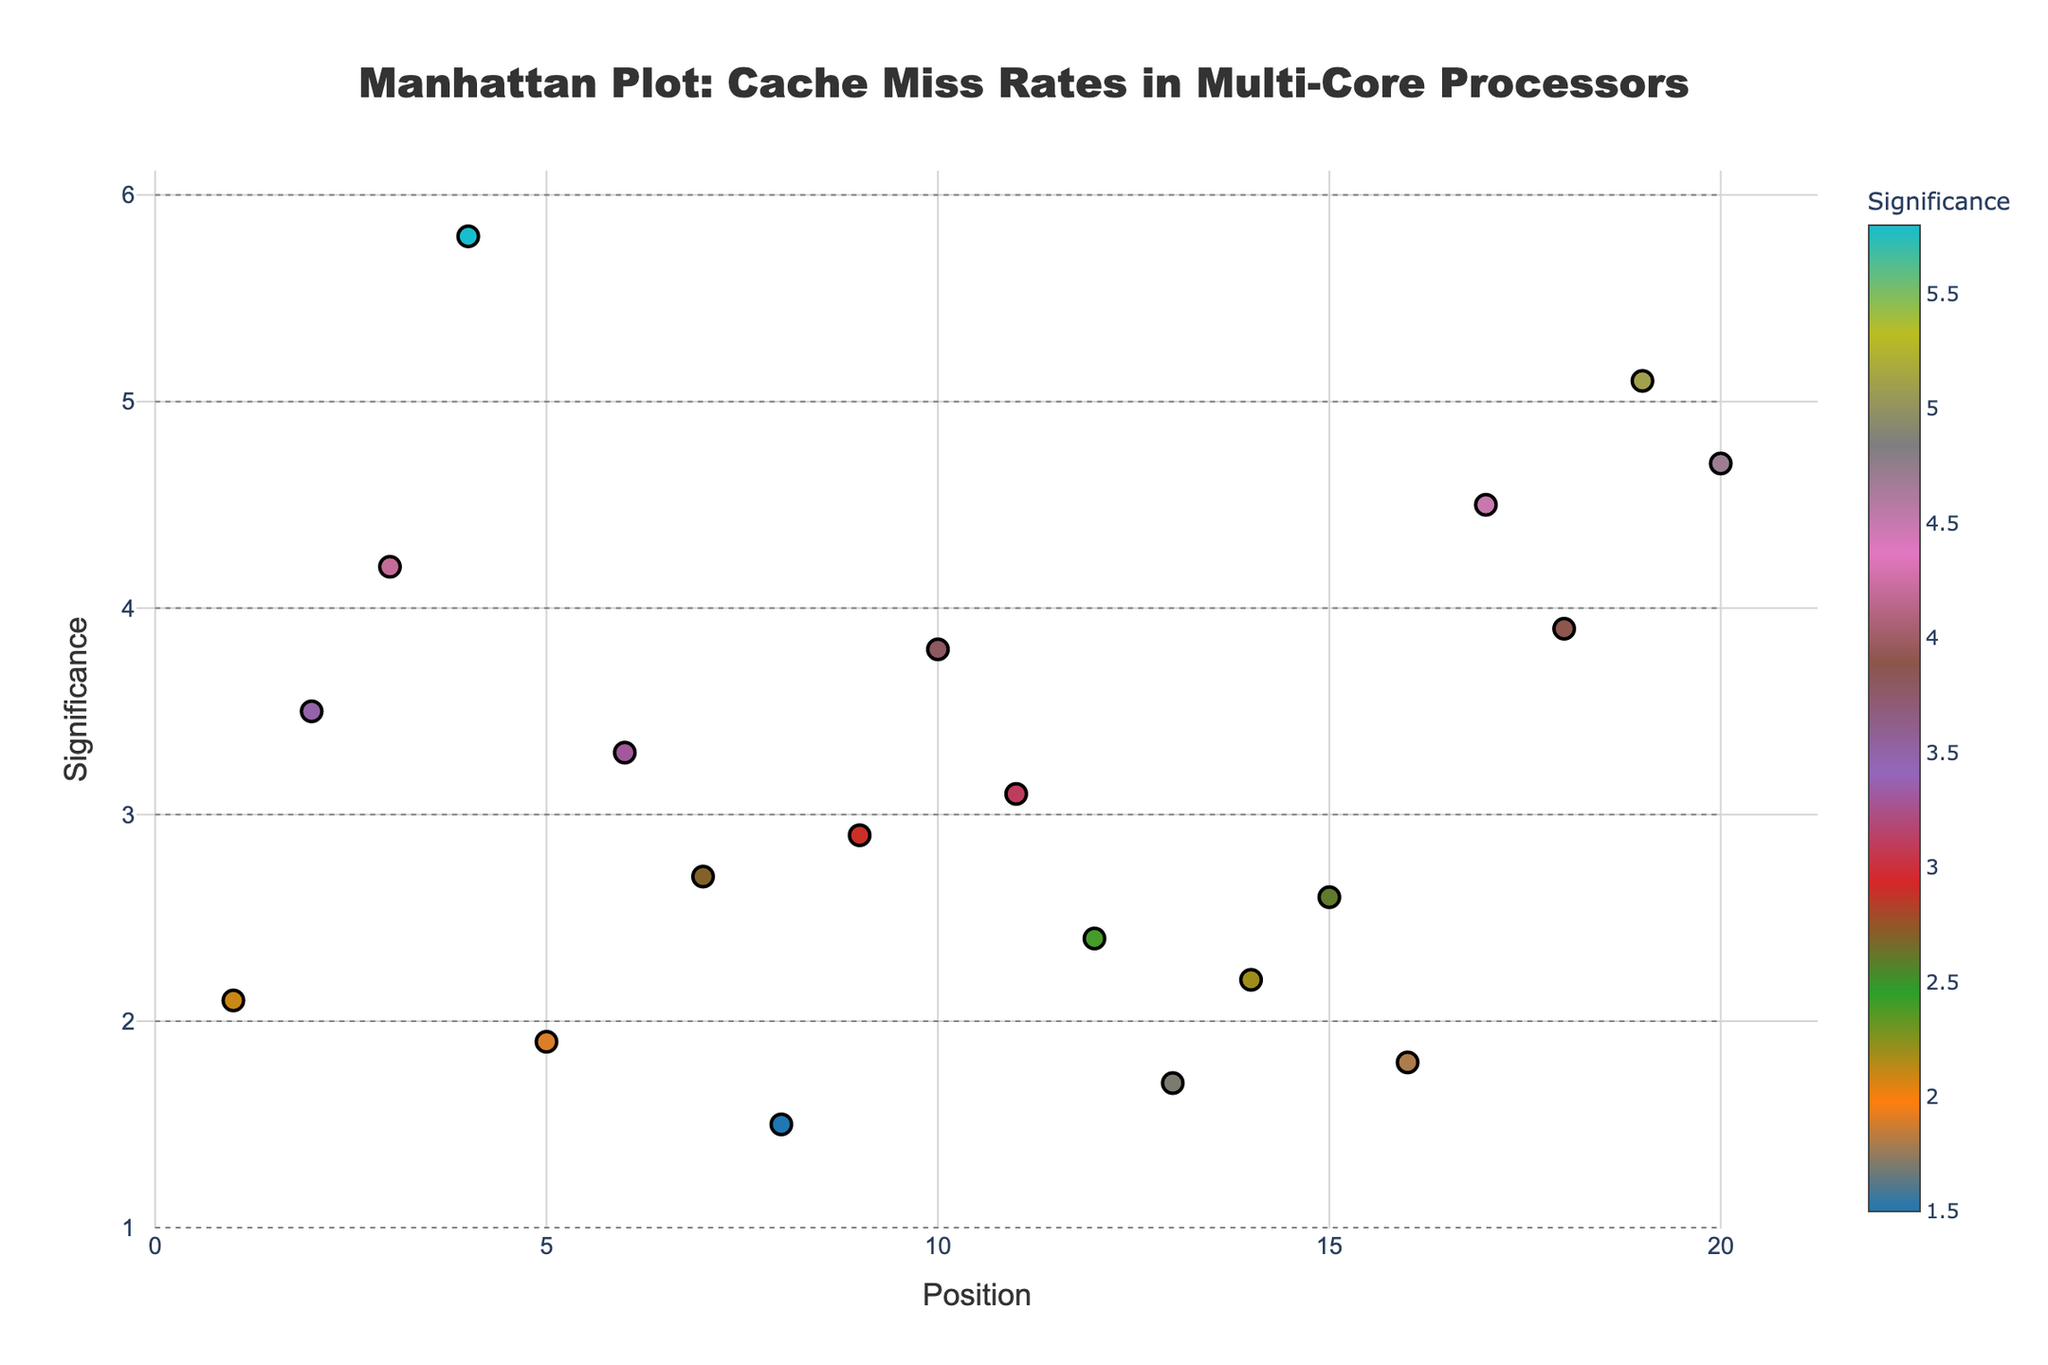What is the title of the plot? The title is displayed at the top center of the plot. It reads "Manhattan Plot: Cache Miss Rates in Multi-Core Processors".
Answer: Manhattan Plot: Cache Miss Rates in Multi-Core Processors How many position labels are there on the x-axis? The x-axis runs from position 1 to 20, which corresponds to the number of data points labeled by position.
Answer: 20 Which cache has the highest significance? Referring to the plot, we look for the point plotted at the maximum value on the y-axis. This point is at position 4 and corresponds to L3_Shared cache.
Answer: L3_Shared What is the significance value of the Bandwidth cache? By locating the Bandwidth cache point on the plot positioned at 20 on the x-axis, the corresponding y-value is 4.7.
Answer: 4.7 Which cache has a significance closest to 3.0? We need to find the points on the plot closest to a y-value of 3.0. The WriteBuffer cache at position 7 with a significance of 2.7 and StoreQueue cache at position 11 with a significance of 3.1 are closest. StoreQueue is the nearest with 3.1.
Answer: StoreQueue What is the average significance of the caches at positions 10, 12, and 15? The significance values at positions 10, 12, and 15 are 3.8, 2.4, and 2.6, respectively. The average is calculated as (3.8 + 2.4 + 2.6) / 3, which equals 2.93.
Answer: 2.93 How many caches have a significance value greater than 3.0? Observing the plots, the caches with a y-value above 3.0 are L1_Data, L2_Unified, L3_Shared, Prefetcher, LoadQueue, MemoryController, CoherenceProtocol, NUMA, Bandwidth, and StoreQueue, making a total of 10.
Answer: 10 Which two caches have the smallest significance values? The caches with the smallest y-values are VictimCache at position 8 with 1.5 and TLB at position 5 with 1.9.
Answer: VictimCache and TLB What is the combined significance value of L2_Unified and NUMA caches? The significance values for L2_Unified and NUMA are 4.2 and 5.1, respectively. Adding these values gives 4.2 + 5.1 = 9.3.
Answer: 9.3 Which position represents the InstructionWindow cache and what is its significance value? The InstructionWindow cache can be identified at position 15 on the plot, and its corresponding significance value is 2.6.
Answer: Position 15, 2.6 